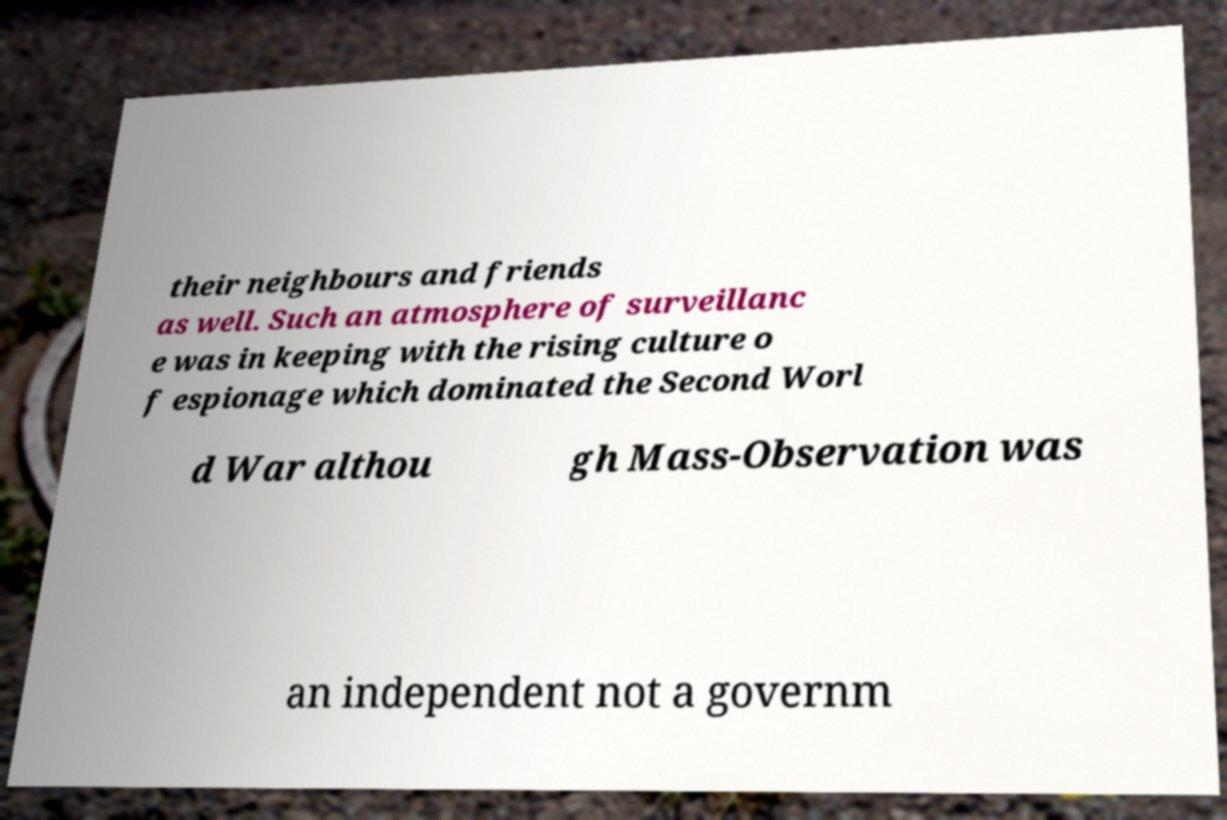Can you read and provide the text displayed in the image?This photo seems to have some interesting text. Can you extract and type it out for me? their neighbours and friends as well. Such an atmosphere of surveillanc e was in keeping with the rising culture o f espionage which dominated the Second Worl d War althou gh Mass-Observation was an independent not a governm 